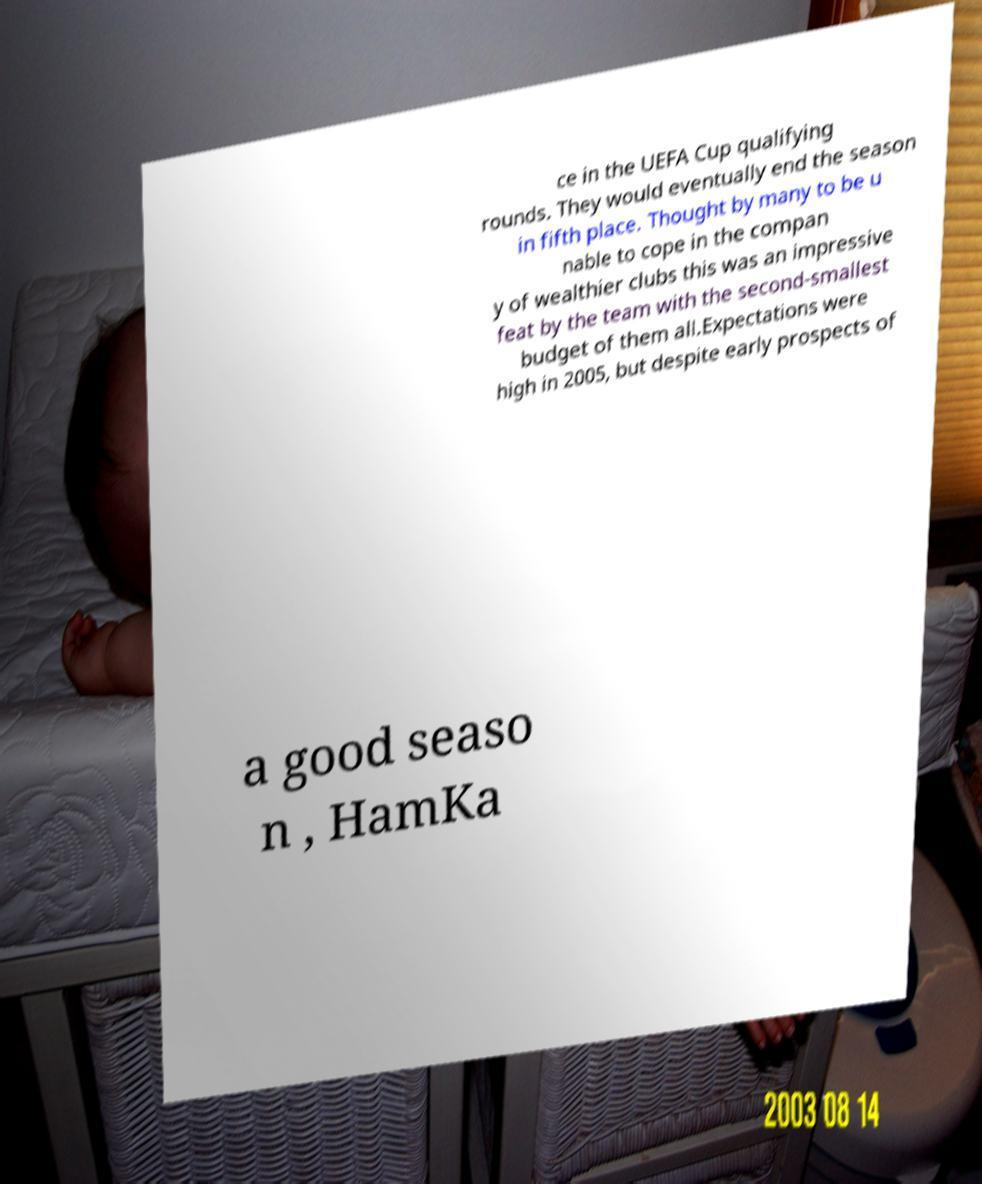Please read and relay the text visible in this image. What does it say? ce in the UEFA Cup qualifying rounds. They would eventually end the season in fifth place. Thought by many to be u nable to cope in the compan y of wealthier clubs this was an impressive feat by the team with the second-smallest budget of them all.Expectations were high in 2005, but despite early prospects of a good seaso n , HamKa 